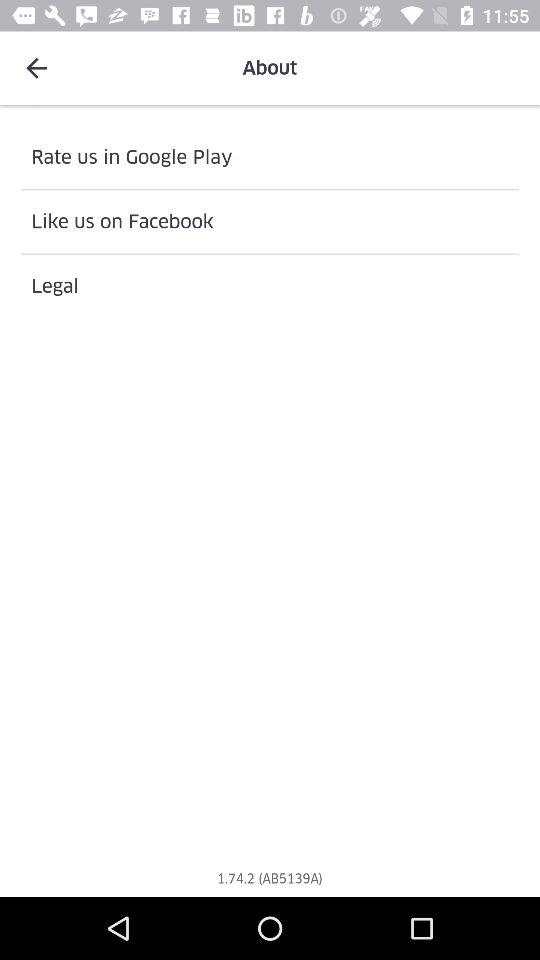What application is used to rate us? You can rate us in "Google Play". 